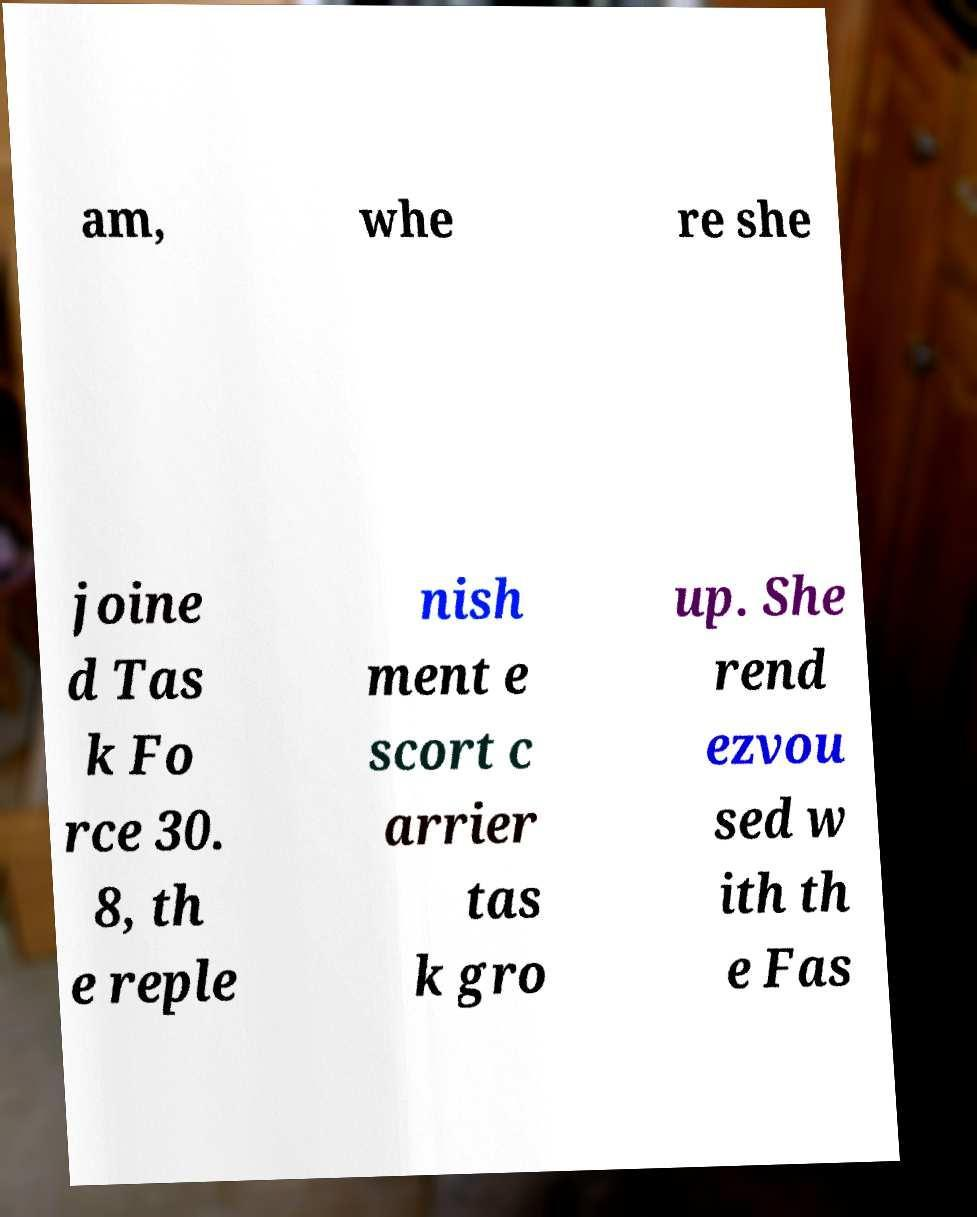Please read and relay the text visible in this image. What does it say? am, whe re she joine d Tas k Fo rce 30. 8, th e reple nish ment e scort c arrier tas k gro up. She rend ezvou sed w ith th e Fas 